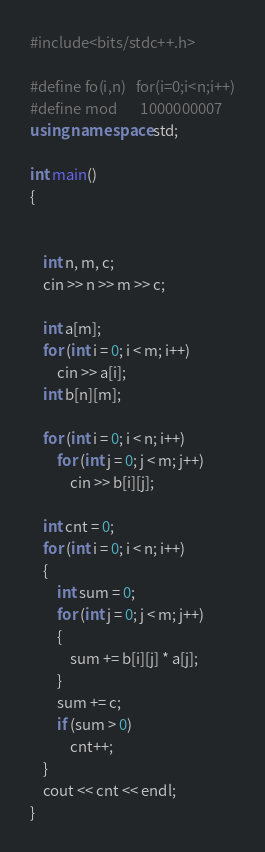<code> <loc_0><loc_0><loc_500><loc_500><_C++_>#include<bits/stdc++.h>

#define fo(i,n)   for(i=0;i<n;i++)
#define mod       1000000007
using namespace std;

int main()
{


	int n, m, c;
	cin >> n >> m >> c;

	int a[m];
	for (int i = 0; i < m; i++)
		cin >> a[i];
	int b[n][m];

	for (int i = 0; i < n; i++)
		for (int j = 0; j < m; j++)
			cin >> b[i][j];

	int cnt = 0;
	for (int i = 0; i < n; i++)
	{
		int sum = 0;
		for (int j = 0; j < m; j++)
		{
			sum += b[i][j] * a[j];
		}
		sum += c;
		if (sum > 0)
			cnt++;
	}
	cout << cnt << endl;
}
</code> 